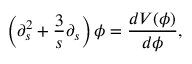<formula> <loc_0><loc_0><loc_500><loc_500>\left ( \partial _ { s } ^ { 2 } + \frac { 3 } { s } \partial _ { s } \right ) \phi = \frac { d V ( \phi ) } { d \phi } ,</formula> 